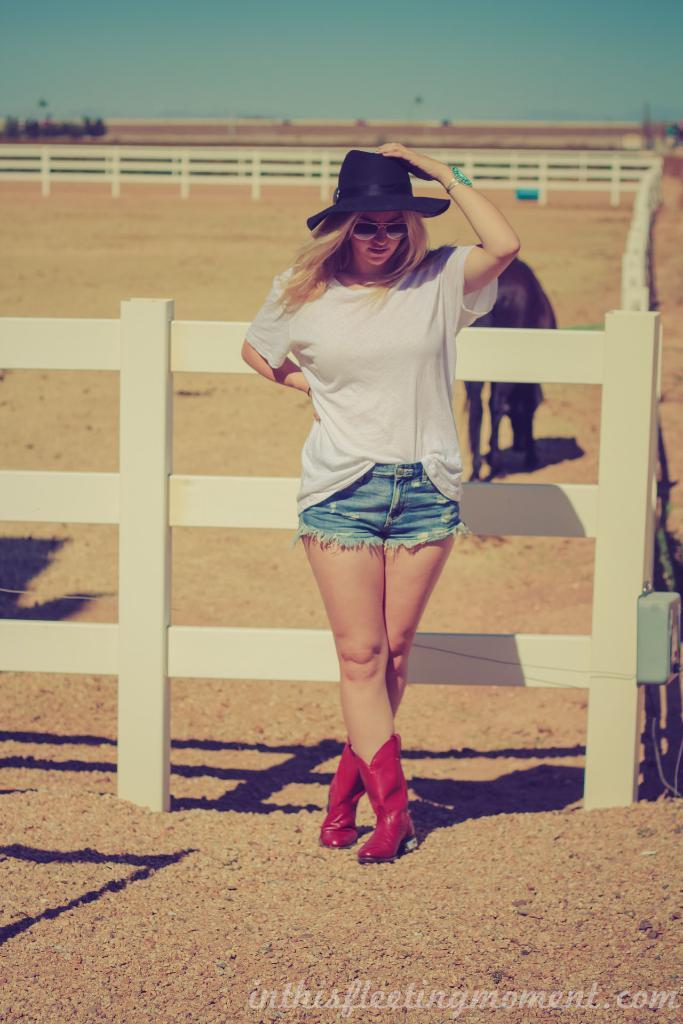Who is the main subject in the image? There is a girl in the center of the image. What other living creature is present in the image? There is an animal in the image. What can be seen surrounding the girl and the animal? There is a boundary in the image. What type of clouds can be seen in the image? There are no clouds visible in the image. Can you tell me how many kittens are playing with the girl in the image? There is no kitten present in the image. 